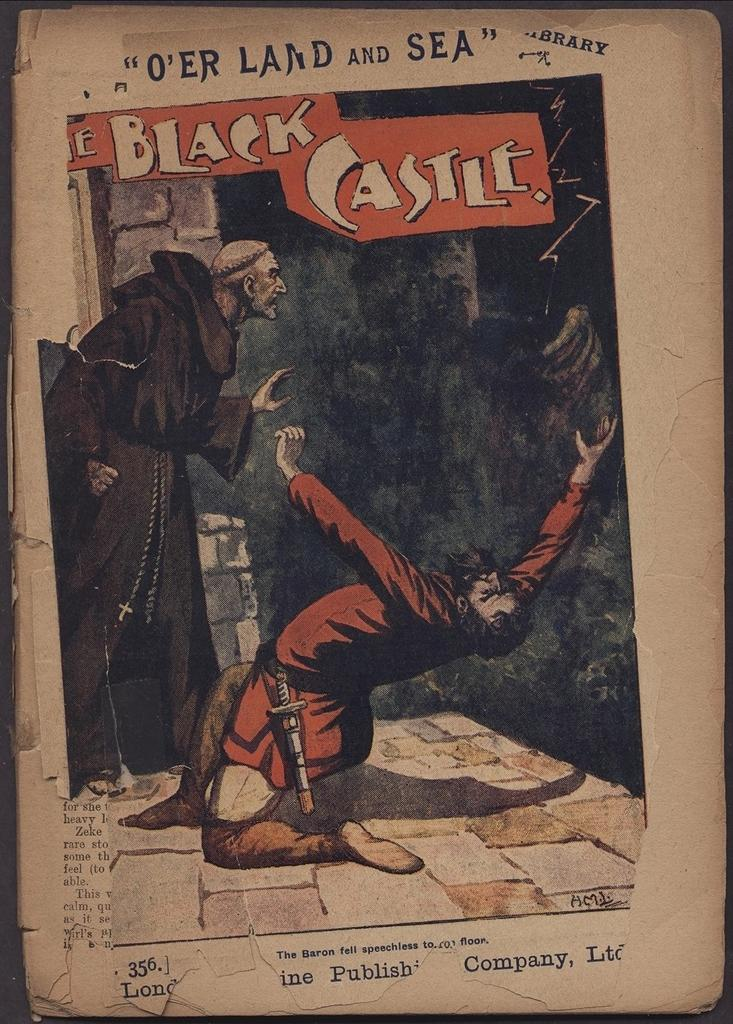<image>
Write a terse but informative summary of the picture. a picture on the cover of the black castle book 